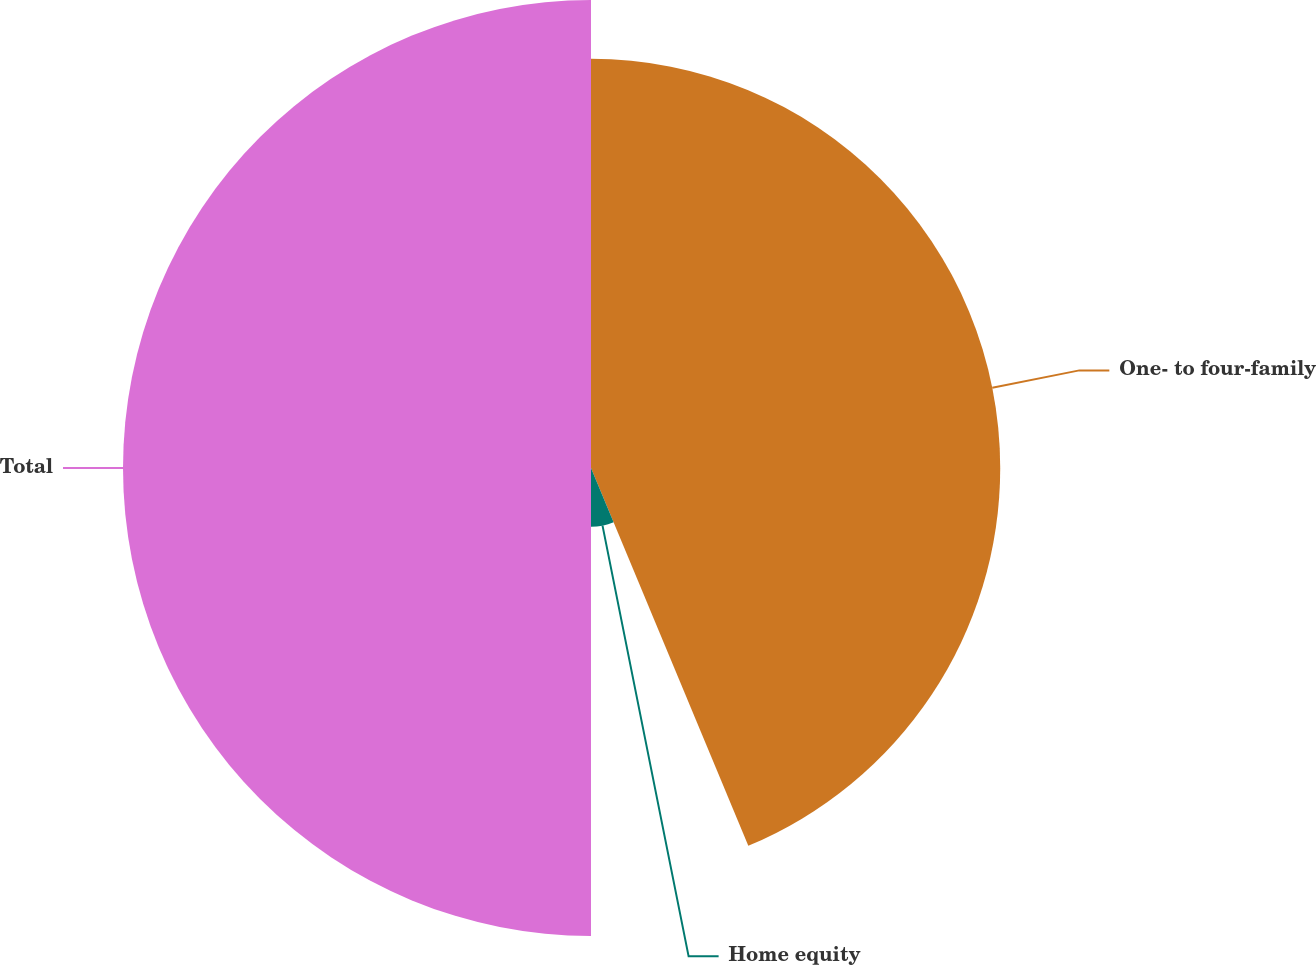Convert chart. <chart><loc_0><loc_0><loc_500><loc_500><pie_chart><fcel>One- to four-family<fcel>Home equity<fcel>Total<nl><fcel>43.72%<fcel>6.28%<fcel>50.0%<nl></chart> 